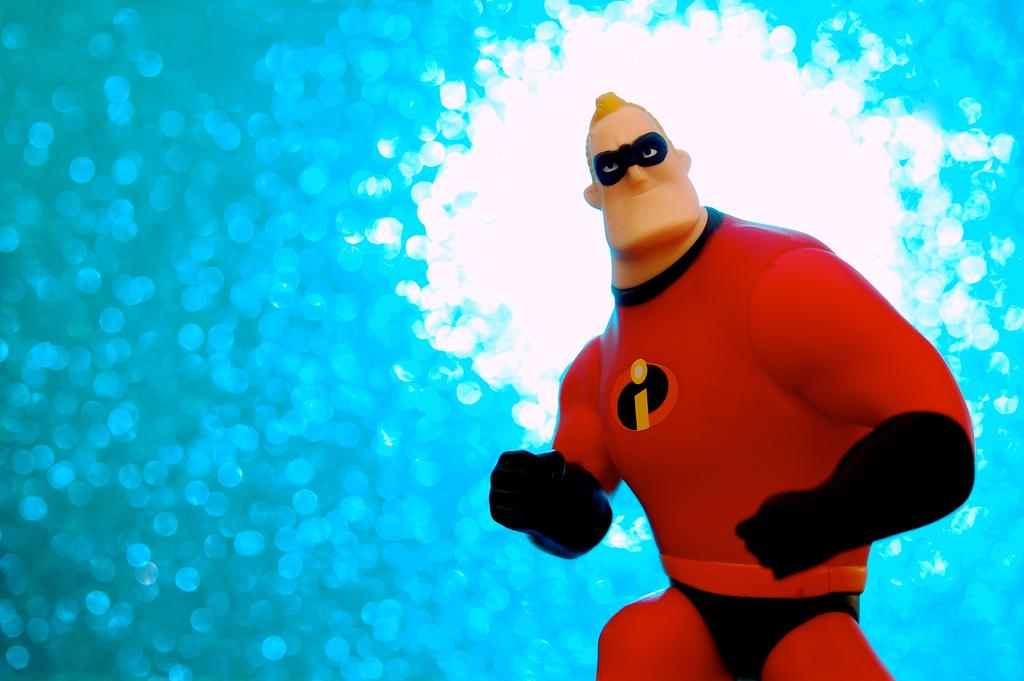What style is the image presented in? The image is a cartoon. What type of bird is flying in the image? There is no bird present in the image, as it is a cartoon and not a photograph or realistic depiction of a scene. 